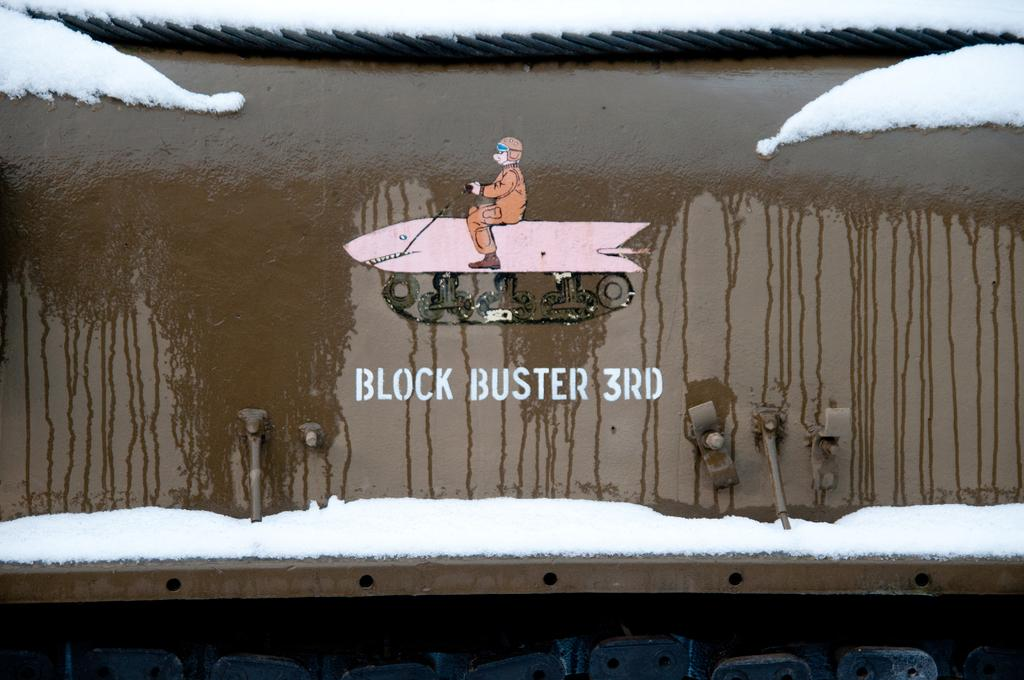<image>
Share a concise interpretation of the image provided. A small picture of a man riding a shark that reads BLOCK BUSTER 3RD. 